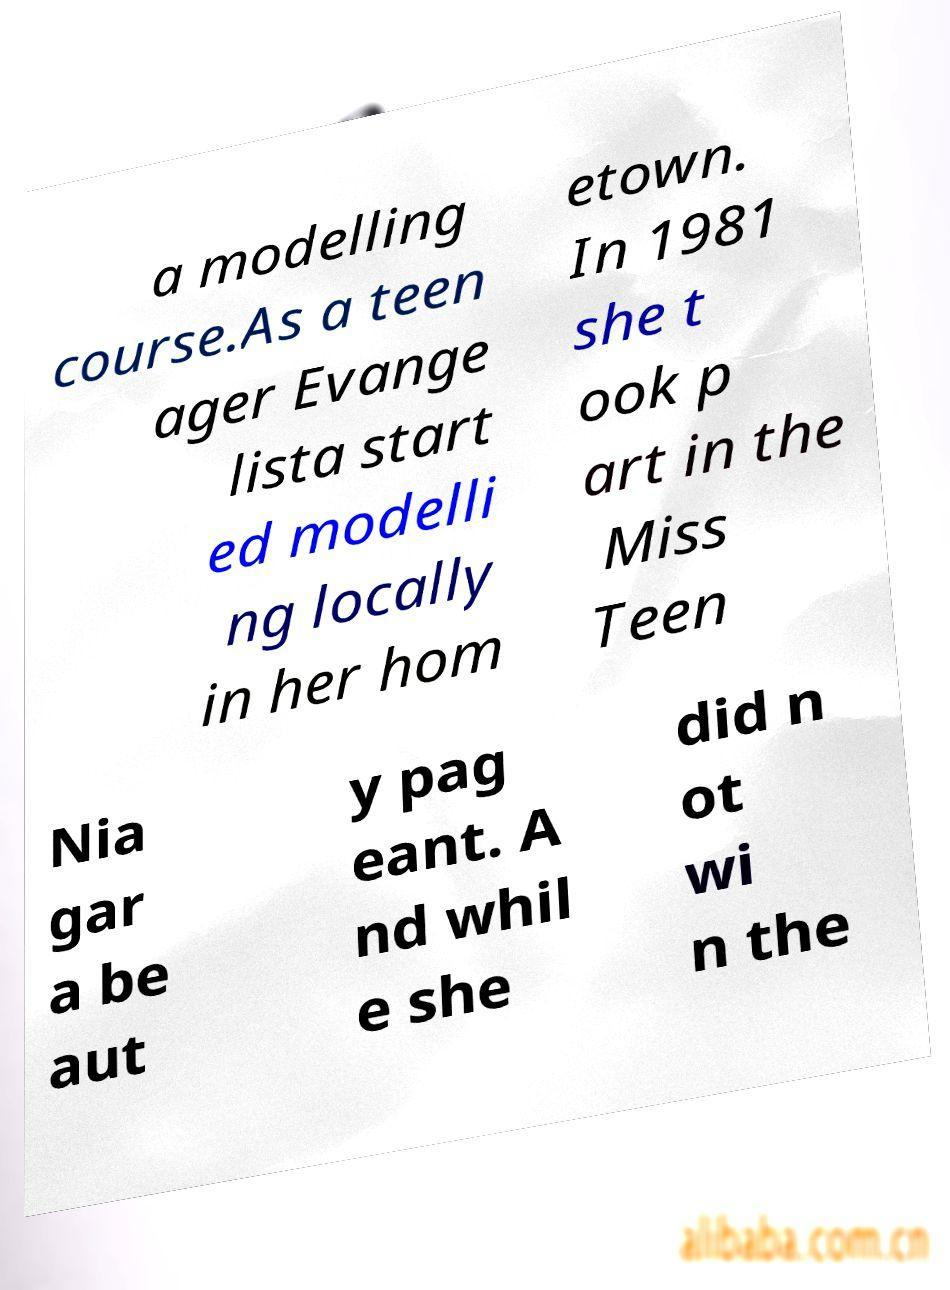Can you accurately transcribe the text from the provided image for me? a modelling course.As a teen ager Evange lista start ed modelli ng locally in her hom etown. In 1981 she t ook p art in the Miss Teen Nia gar a be aut y pag eant. A nd whil e she did n ot wi n the 